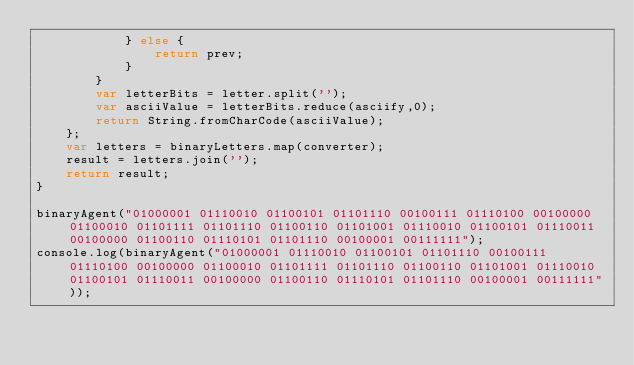Convert code to text. <code><loc_0><loc_0><loc_500><loc_500><_JavaScript_>            } else {
                return prev;
            }        
        }
        var letterBits = letter.split('');
        var asciiValue = letterBits.reduce(asciify,0);
        return String.fromCharCode(asciiValue);
    };
    var letters = binaryLetters.map(converter);
    result = letters.join('');
    return result;
}

binaryAgent("01000001 01110010 01100101 01101110 00100111 01110100 00100000 01100010 01101111 01101110 01100110 01101001 01110010 01100101 01110011 00100000 01100110 01110101 01101110 00100001 00111111");
console.log(binaryAgent("01000001 01110010 01100101 01101110 00100111 01110100 00100000 01100010 01101111 01101110 01100110 01101001 01110010 01100101 01110011 00100000 01100110 01110101 01101110 00100001 00111111"));
</code> 